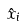Convert formula to latex. <formula><loc_0><loc_0><loc_500><loc_500>\hat { x } _ { i }</formula> 